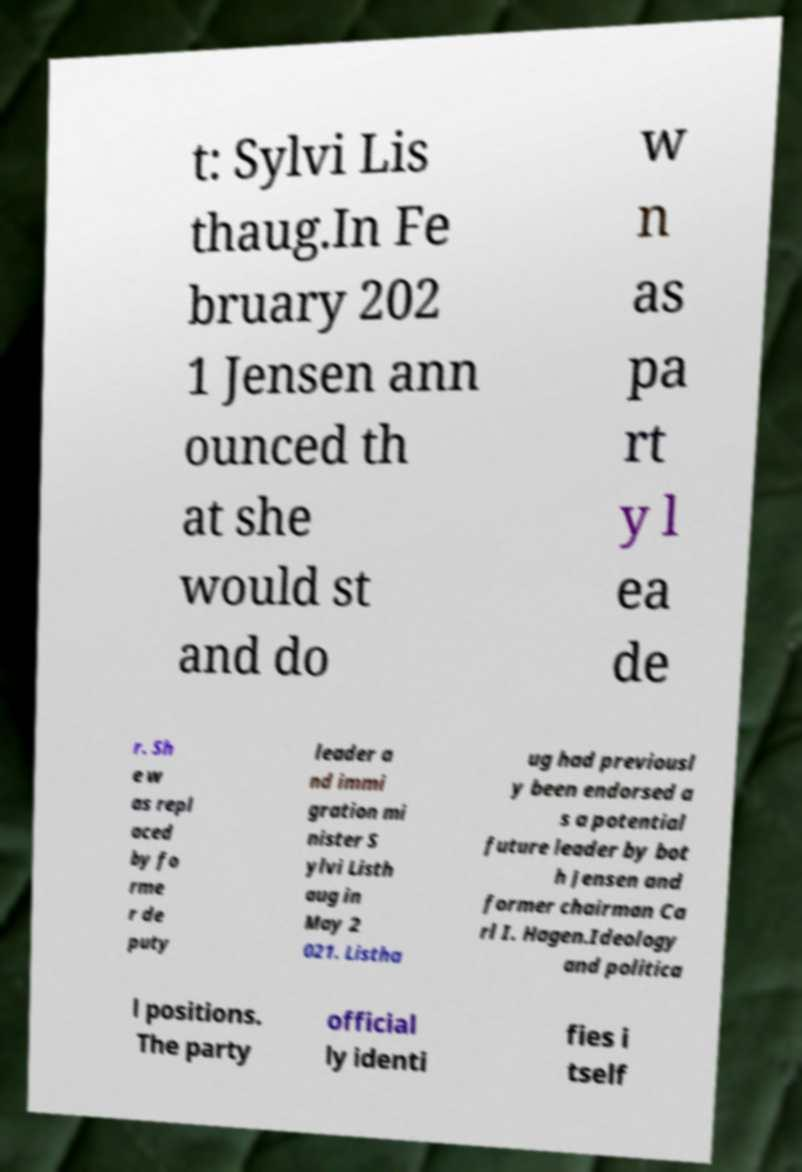What messages or text are displayed in this image? I need them in a readable, typed format. t: Sylvi Lis thaug.In Fe bruary 202 1 Jensen ann ounced th at she would st and do w n as pa rt y l ea de r. Sh e w as repl aced by fo rme r de puty leader a nd immi gration mi nister S ylvi Listh aug in May 2 021. Listha ug had previousl y been endorsed a s a potential future leader by bot h Jensen and former chairman Ca rl I. Hagen.Ideology and politica l positions. The party official ly identi fies i tself 